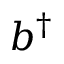Convert formula to latex. <formula><loc_0><loc_0><loc_500><loc_500>b ^ { \dagger }</formula> 